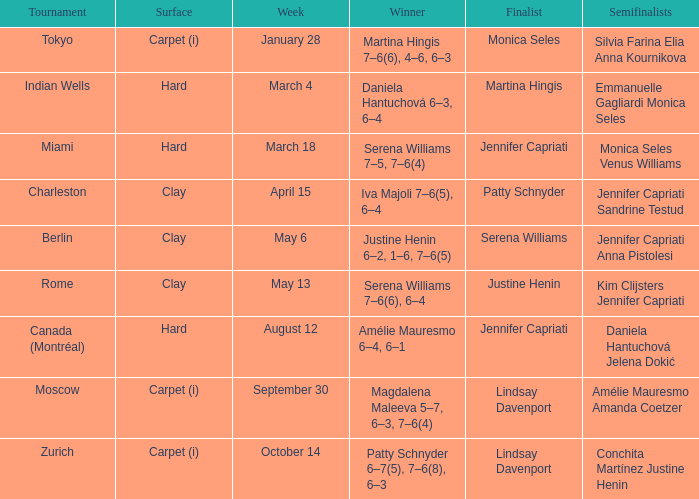In which tournament did monica seles become a finalist? Tokyo. 